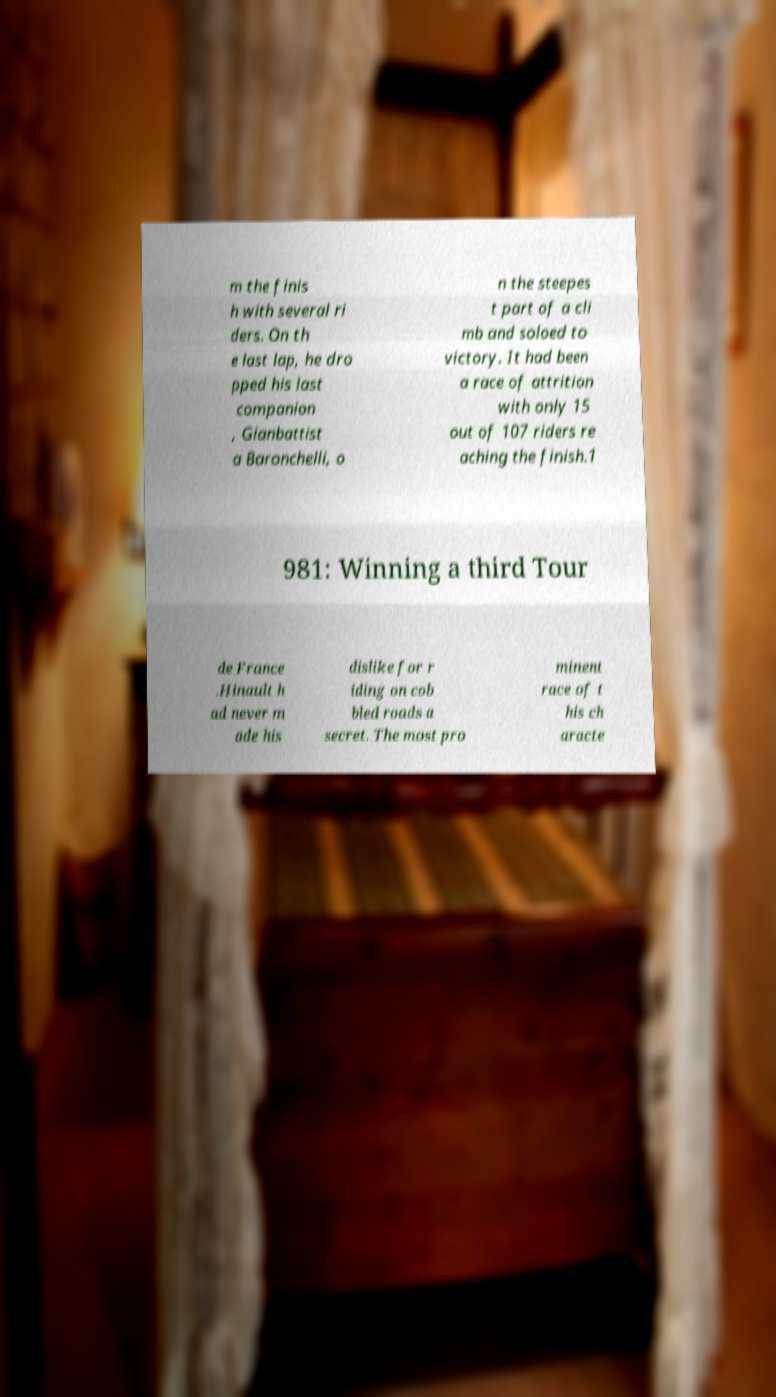Could you assist in decoding the text presented in this image and type it out clearly? m the finis h with several ri ders. On th e last lap, he dro pped his last companion , Gianbattist a Baronchelli, o n the steepes t part of a cli mb and soloed to victory. It had been a race of attrition with only 15 out of 107 riders re aching the finish.1 981: Winning a third Tour de France .Hinault h ad never m ade his dislike for r iding on cob bled roads a secret. The most pro minent race of t his ch aracte 